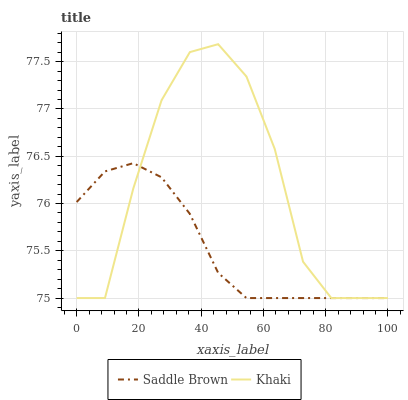Does Saddle Brown have the minimum area under the curve?
Answer yes or no. Yes. Does Khaki have the maximum area under the curve?
Answer yes or no. Yes. Does Saddle Brown have the maximum area under the curve?
Answer yes or no. No. Is Saddle Brown the smoothest?
Answer yes or no. Yes. Is Khaki the roughest?
Answer yes or no. Yes. Is Saddle Brown the roughest?
Answer yes or no. No. Does Khaki have the highest value?
Answer yes or no. Yes. Does Saddle Brown have the highest value?
Answer yes or no. No. Does Saddle Brown intersect Khaki?
Answer yes or no. Yes. Is Saddle Brown less than Khaki?
Answer yes or no. No. Is Saddle Brown greater than Khaki?
Answer yes or no. No. 